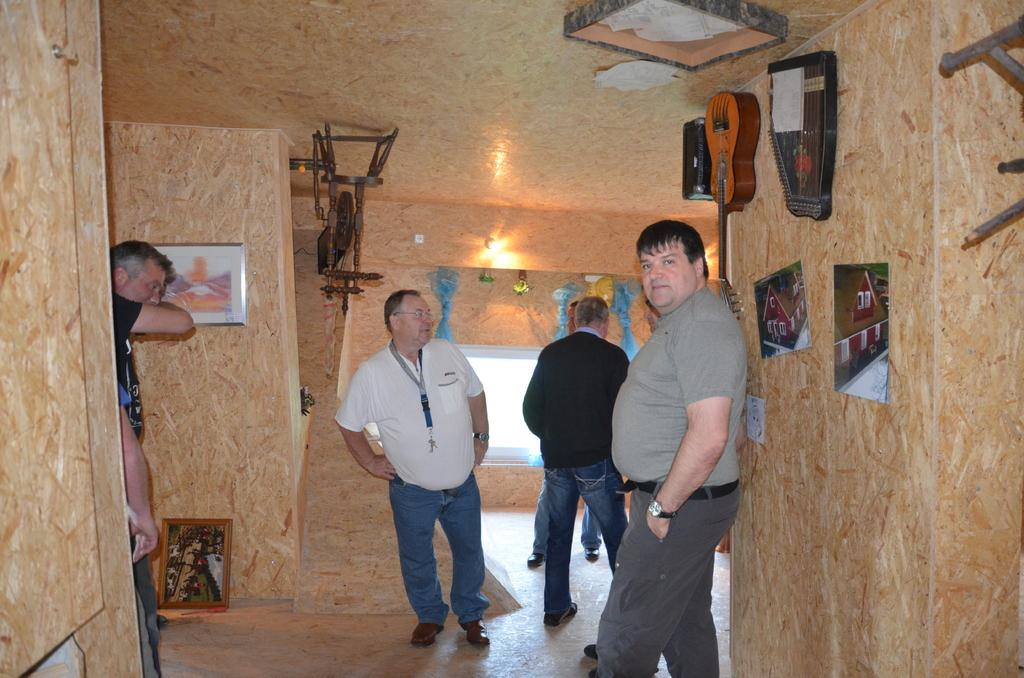Where are the people located in the image? The people are inside a building. What can be seen hanging on the walls in the image? There is a guitar on the wall. What type of decorative items are visible in the image? There are frames visible in the image. What color of paint is being used to draw attention to the value of the guitar in the image? There is no mention of paint or value in the image, and the focus is on the guitar's presence on the wall. 